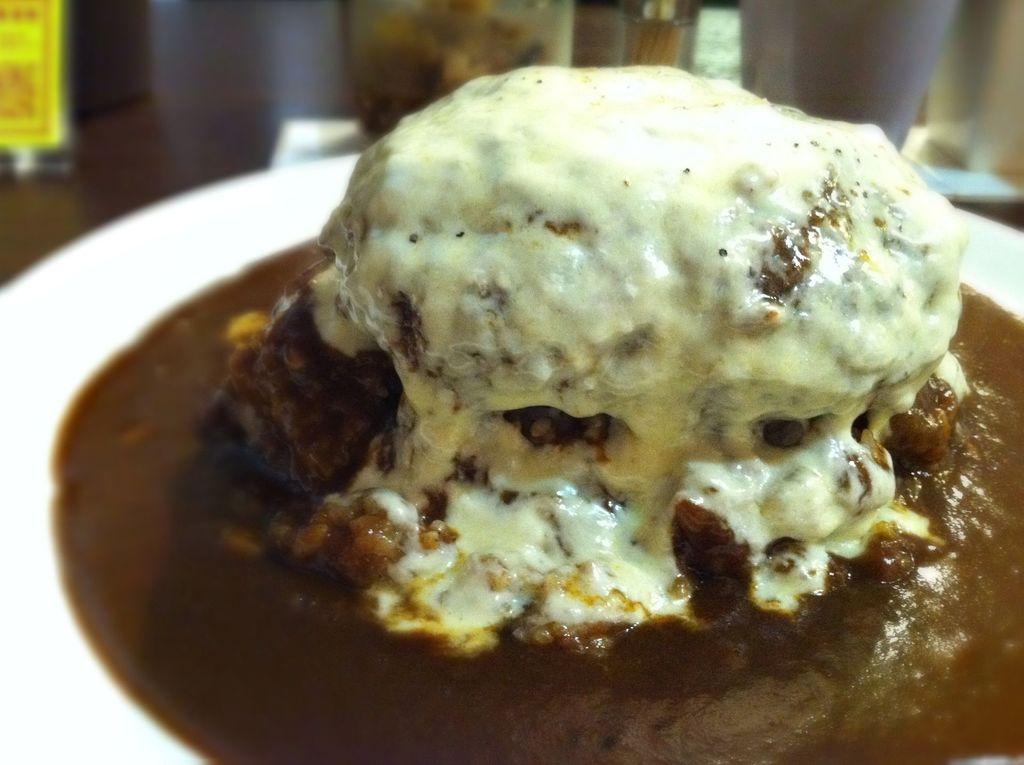Can you describe this image briefly? In this image we can see a dessert on the serving plate. 